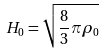<formula> <loc_0><loc_0><loc_500><loc_500>H _ { 0 } = \sqrt { \frac { 8 } { 3 } \pi \rho _ { 0 } }</formula> 